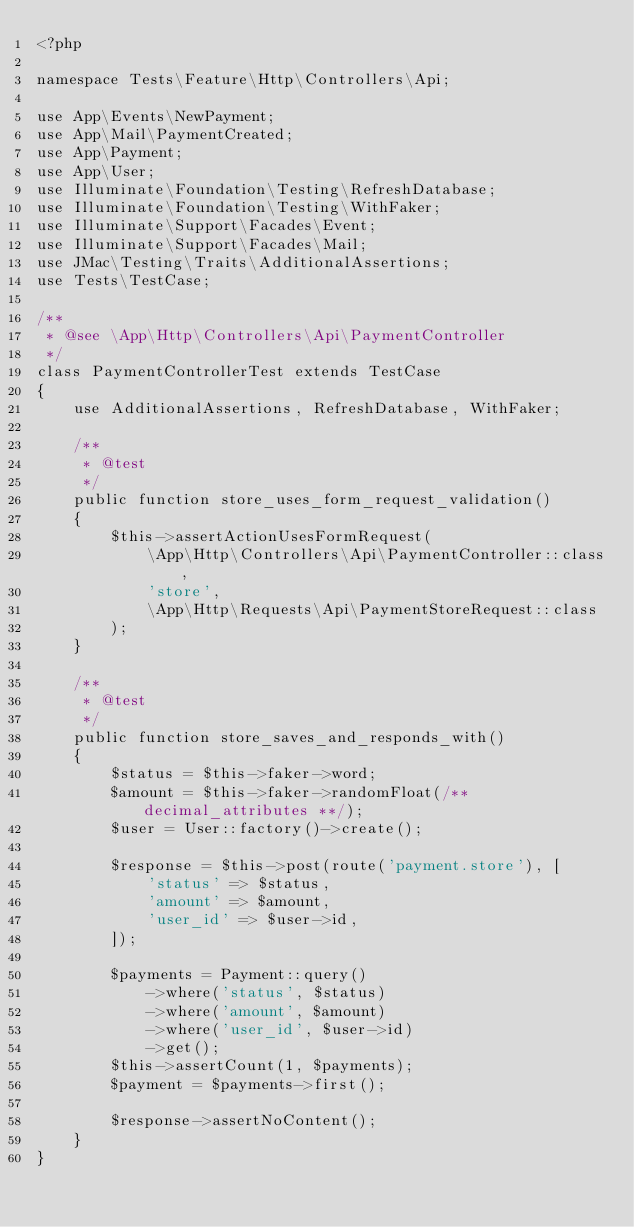<code> <loc_0><loc_0><loc_500><loc_500><_PHP_><?php

namespace Tests\Feature\Http\Controllers\Api;

use App\Events\NewPayment;
use App\Mail\PaymentCreated;
use App\Payment;
use App\User;
use Illuminate\Foundation\Testing\RefreshDatabase;
use Illuminate\Foundation\Testing\WithFaker;
use Illuminate\Support\Facades\Event;
use Illuminate\Support\Facades\Mail;
use JMac\Testing\Traits\AdditionalAssertions;
use Tests\TestCase;

/**
 * @see \App\Http\Controllers\Api\PaymentController
 */
class PaymentControllerTest extends TestCase
{
    use AdditionalAssertions, RefreshDatabase, WithFaker;

    /**
     * @test
     */
    public function store_uses_form_request_validation()
    {
        $this->assertActionUsesFormRequest(
            \App\Http\Controllers\Api\PaymentController::class,
            'store',
            \App\Http\Requests\Api\PaymentStoreRequest::class
        );
    }

    /**
     * @test
     */
    public function store_saves_and_responds_with()
    {
        $status = $this->faker->word;
        $amount = $this->faker->randomFloat(/** decimal_attributes **/);
        $user = User::factory()->create();

        $response = $this->post(route('payment.store'), [
            'status' => $status,
            'amount' => $amount,
            'user_id' => $user->id,
        ]);

        $payments = Payment::query()
            ->where('status', $status)
            ->where('amount', $amount)
            ->where('user_id', $user->id)
            ->get();
        $this->assertCount(1, $payments);
        $payment = $payments->first();

        $response->assertNoContent();
    }
}
</code> 